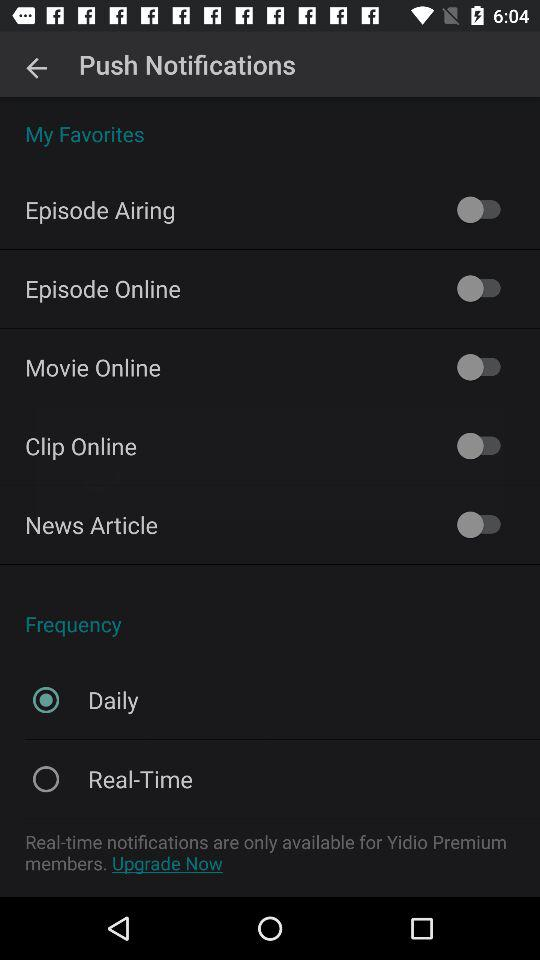What option is selected for the "Frequency" setting? The selected option is "Daily". 